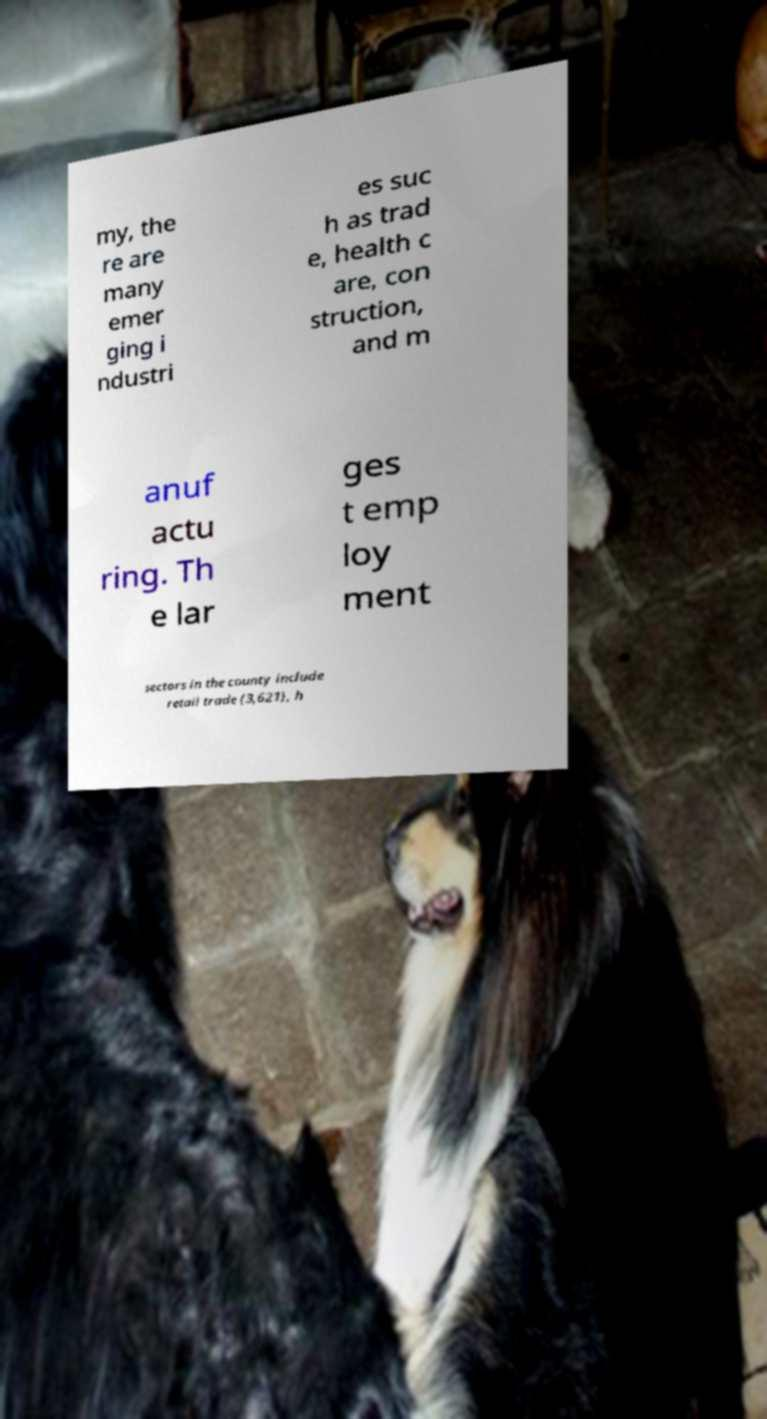Could you assist in decoding the text presented in this image and type it out clearly? my, the re are many emer ging i ndustri es suc h as trad e, health c are, con struction, and m anuf actu ring. Th e lar ges t emp loy ment sectors in the county include retail trade (3,621), h 